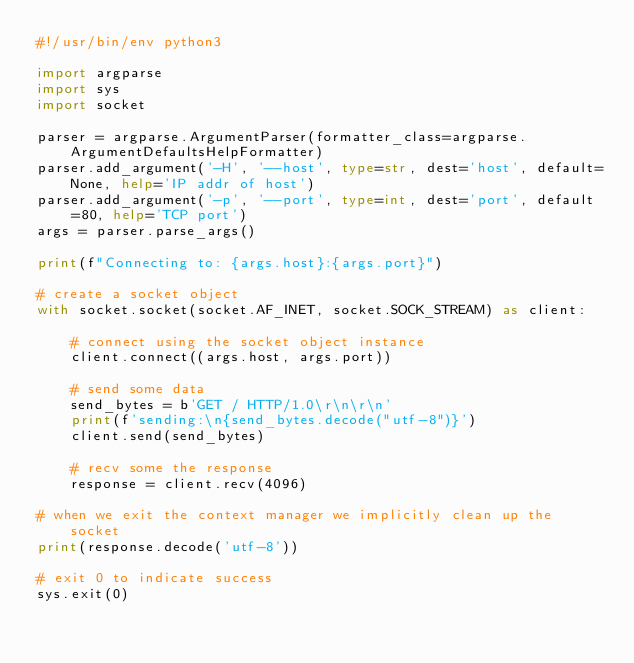<code> <loc_0><loc_0><loc_500><loc_500><_Python_>#!/usr/bin/env python3

import argparse
import sys
import socket

parser = argparse.ArgumentParser(formatter_class=argparse.ArgumentDefaultsHelpFormatter)
parser.add_argument('-H', '--host', type=str, dest='host', default=None, help='IP addr of host')
parser.add_argument('-p', '--port', type=int, dest='port', default=80, help='TCP port')
args = parser.parse_args()

print(f"Connecting to: {args.host}:{args.port}")

# create a socket object
with socket.socket(socket.AF_INET, socket.SOCK_STREAM) as client:

    # connect using the socket object instance
    client.connect((args.host, args.port))

    # send some data
    send_bytes = b'GET / HTTP/1.0\r\n\r\n'
    print(f'sending:\n{send_bytes.decode("utf-8")}')
    client.send(send_bytes)

    # recv some the response
    response = client.recv(4096)

# when we exit the context manager we implicitly clean up the socket
print(response.decode('utf-8'))

# exit 0 to indicate success
sys.exit(0)
</code> 